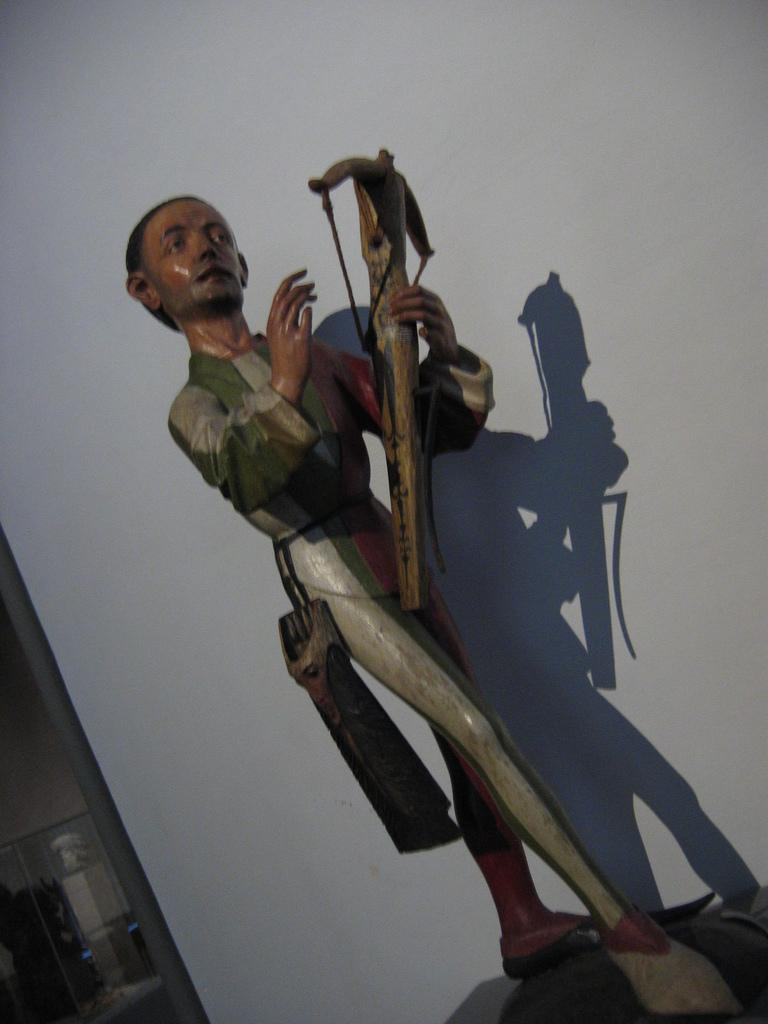What is the main subject in the foreground of the picture? There is a toy person in the foreground of the picture. What is the toy person doing in the picture? The toy person is standing and holding a bow in his hand. What can be seen in the background of the picture? There is a wall in the background of the picture. What type of produce is being stored in the crate in the image? There is no crate or produce present in the image. What action is the toy person performing in the image? The toy person is standing and holding a bow in his hand. 